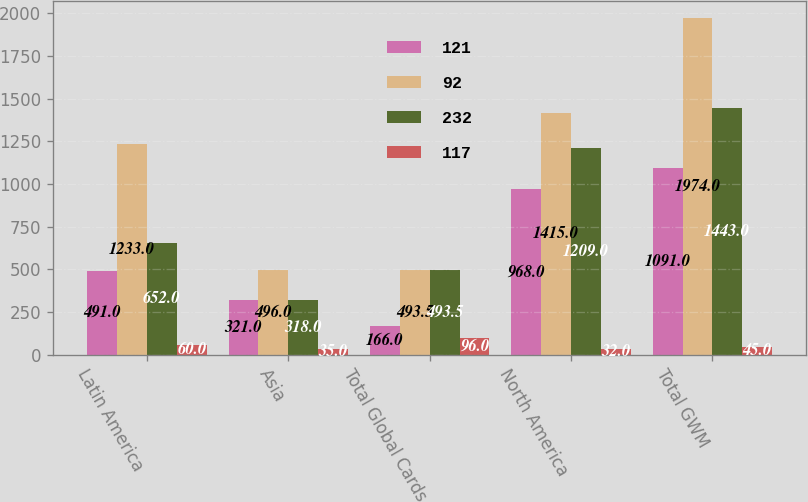<chart> <loc_0><loc_0><loc_500><loc_500><stacked_bar_chart><ecel><fcel>Latin America<fcel>Asia<fcel>Total Global Cards<fcel>North America<fcel>Total GWM<nl><fcel>121<fcel>491<fcel>321<fcel>166<fcel>968<fcel>1091<nl><fcel>92<fcel>1233<fcel>496<fcel>493.5<fcel>1415<fcel>1974<nl><fcel>232<fcel>652<fcel>318<fcel>493.5<fcel>1209<fcel>1443<nl><fcel>117<fcel>60<fcel>35<fcel>96<fcel>32<fcel>45<nl></chart> 